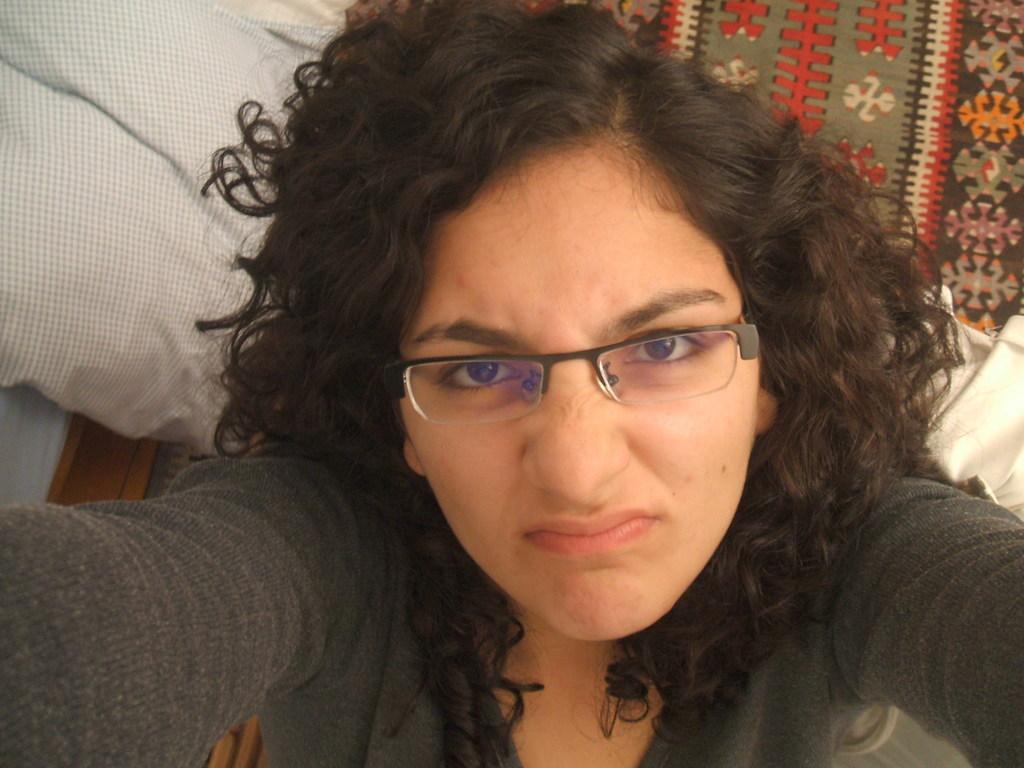Describe this image in one or two sentences. This picture shows a woman. She wore a spectacles on her face and she wore a black color t-shirt and we see a pillow and a blanket. 